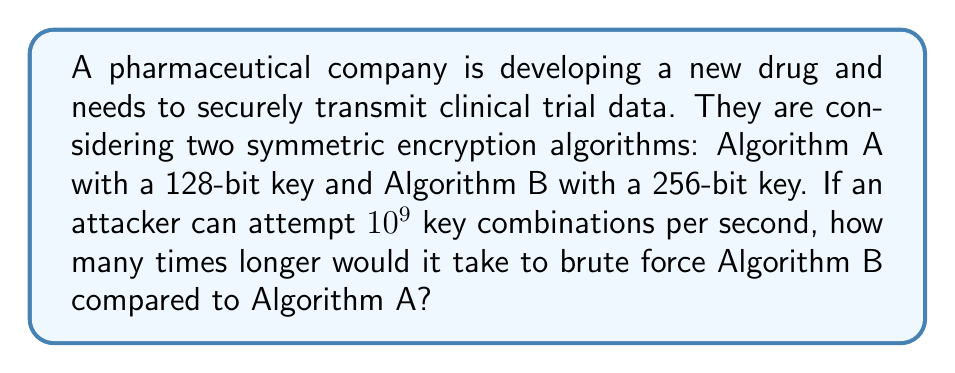Could you help me with this problem? Let's approach this step-by-step:

1) For a symmetric encryption algorithm with a key length of $n$ bits, there are $2^n$ possible keys.

2) For Algorithm A (128-bit key):
   Number of possible keys = $2^{128}$

3) For Algorithm B (256-bit key):
   Number of possible keys = $2^{256}$

4) Time to brute force Algorithm A:
   $T_A = \frac{2^{128}}{10^9}$ seconds

5) Time to brute force Algorithm B:
   $T_B = \frac{2^{256}}{10^9}$ seconds

6) The ratio of these times will give us how many times longer it takes to brute force Algorithm B:

   $$\frac{T_B}{T_A} = \frac{2^{256}/10^9}{2^{128}/10^9} = \frac{2^{256}}{2^{128}} = 2^{256-128} = 2^{128}$$

7) Therefore, it would take $2^{128}$ times longer to brute force Algorithm B compared to Algorithm A.
Answer: $2^{128}$ 